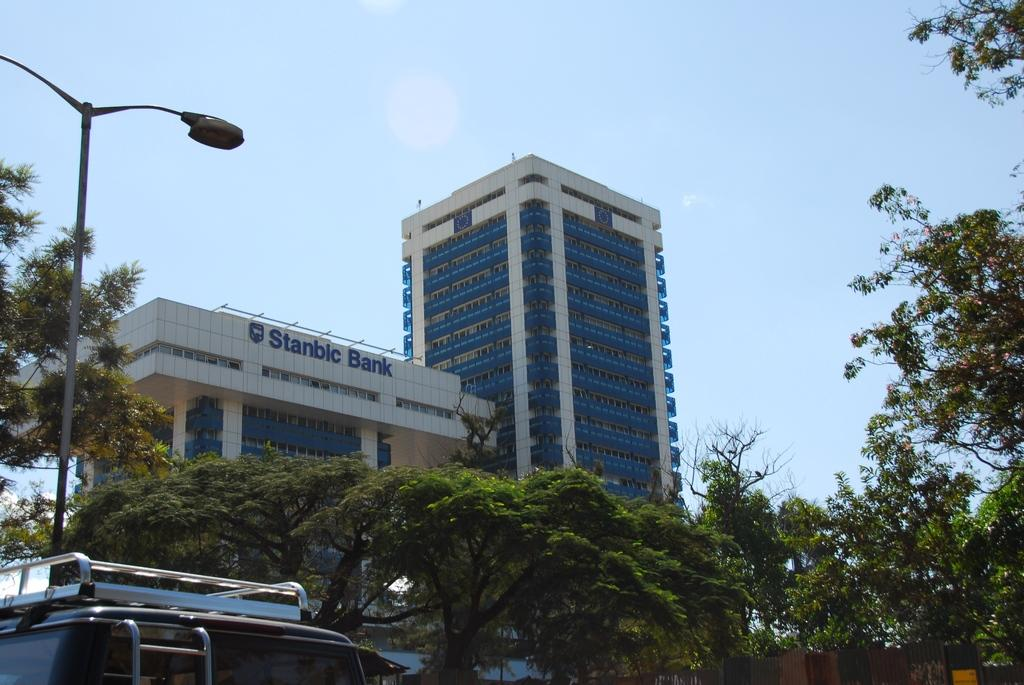What can be seen in the left corner of the image? There is a vehicle in the left corner of the image. What is visible in the background of the image? There are trees and a building in the background of the image. What type of needle is being used to sew the border in the image? There is no needle or sewing activity present in the image. 